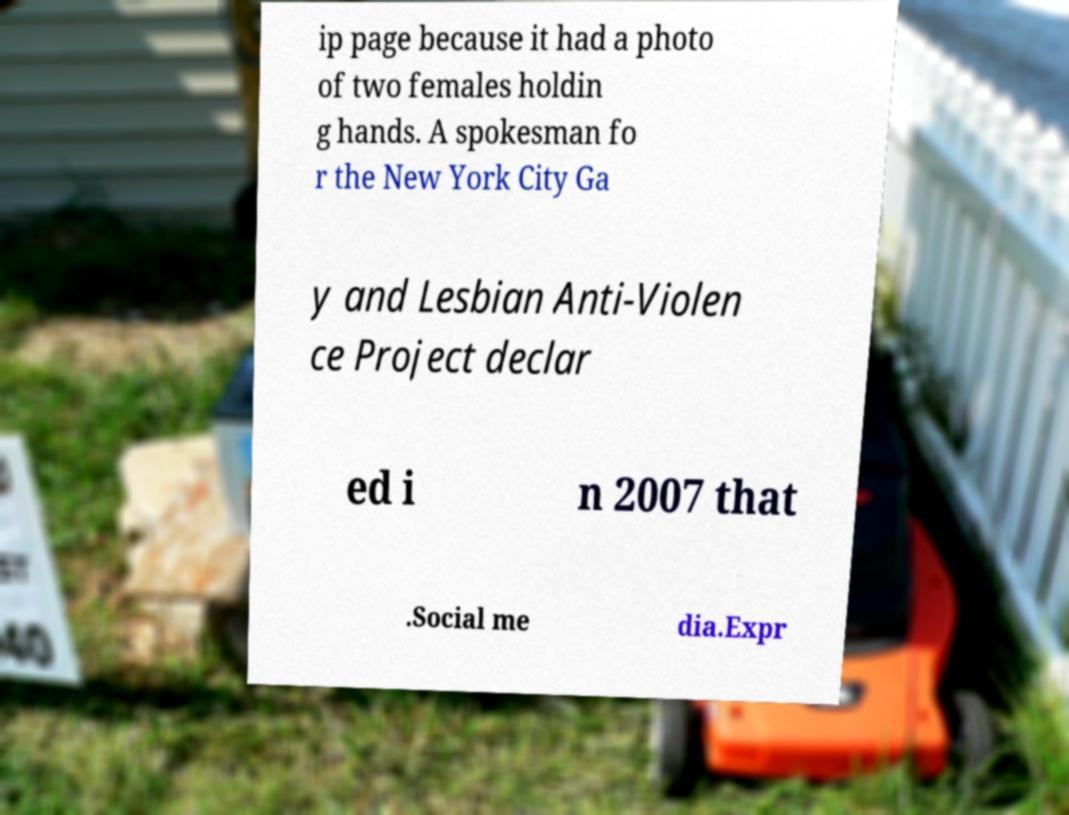What messages or text are displayed in this image? I need them in a readable, typed format. ip page because it had a photo of two females holdin g hands. A spokesman fo r the New York City Ga y and Lesbian Anti-Violen ce Project declar ed i n 2007 that .Social me dia.Expr 